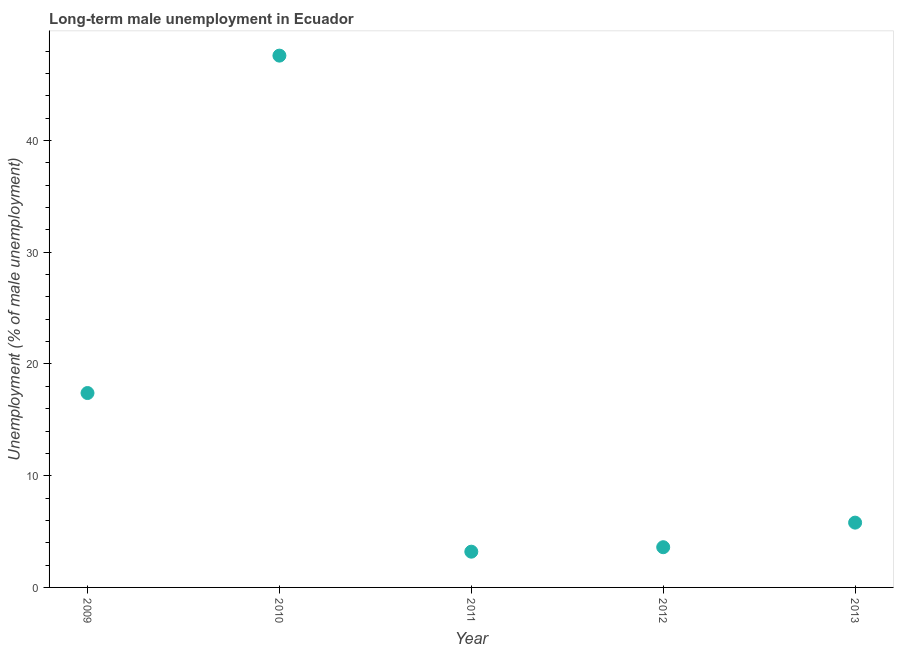What is the long-term male unemployment in 2012?
Your answer should be very brief. 3.6. Across all years, what is the maximum long-term male unemployment?
Ensure brevity in your answer.  47.6. Across all years, what is the minimum long-term male unemployment?
Make the answer very short. 3.2. What is the sum of the long-term male unemployment?
Keep it short and to the point. 77.6. What is the difference between the long-term male unemployment in 2012 and 2013?
Give a very brief answer. -2.2. What is the average long-term male unemployment per year?
Provide a short and direct response. 15.52. What is the median long-term male unemployment?
Offer a terse response. 5.8. In how many years, is the long-term male unemployment greater than 4 %?
Provide a short and direct response. 3. What is the ratio of the long-term male unemployment in 2009 to that in 2013?
Offer a very short reply. 3. Is the long-term male unemployment in 2009 less than that in 2012?
Your answer should be compact. No. Is the difference between the long-term male unemployment in 2010 and 2011 greater than the difference between any two years?
Provide a succinct answer. Yes. What is the difference between the highest and the second highest long-term male unemployment?
Give a very brief answer. 30.2. What is the difference between the highest and the lowest long-term male unemployment?
Give a very brief answer. 44.4. In how many years, is the long-term male unemployment greater than the average long-term male unemployment taken over all years?
Give a very brief answer. 2. Are the values on the major ticks of Y-axis written in scientific E-notation?
Your answer should be very brief. No. Does the graph contain grids?
Give a very brief answer. No. What is the title of the graph?
Your response must be concise. Long-term male unemployment in Ecuador. What is the label or title of the X-axis?
Your response must be concise. Year. What is the label or title of the Y-axis?
Offer a terse response. Unemployment (% of male unemployment). What is the Unemployment (% of male unemployment) in 2009?
Give a very brief answer. 17.4. What is the Unemployment (% of male unemployment) in 2010?
Provide a succinct answer. 47.6. What is the Unemployment (% of male unemployment) in 2011?
Provide a succinct answer. 3.2. What is the Unemployment (% of male unemployment) in 2012?
Offer a terse response. 3.6. What is the Unemployment (% of male unemployment) in 2013?
Offer a terse response. 5.8. What is the difference between the Unemployment (% of male unemployment) in 2009 and 2010?
Ensure brevity in your answer.  -30.2. What is the difference between the Unemployment (% of male unemployment) in 2009 and 2013?
Make the answer very short. 11.6. What is the difference between the Unemployment (% of male unemployment) in 2010 and 2011?
Provide a short and direct response. 44.4. What is the difference between the Unemployment (% of male unemployment) in 2010 and 2013?
Offer a very short reply. 41.8. What is the difference between the Unemployment (% of male unemployment) in 2012 and 2013?
Your answer should be very brief. -2.2. What is the ratio of the Unemployment (% of male unemployment) in 2009 to that in 2010?
Your answer should be compact. 0.37. What is the ratio of the Unemployment (% of male unemployment) in 2009 to that in 2011?
Ensure brevity in your answer.  5.44. What is the ratio of the Unemployment (% of male unemployment) in 2009 to that in 2012?
Provide a succinct answer. 4.83. What is the ratio of the Unemployment (% of male unemployment) in 2009 to that in 2013?
Ensure brevity in your answer.  3. What is the ratio of the Unemployment (% of male unemployment) in 2010 to that in 2011?
Offer a very short reply. 14.88. What is the ratio of the Unemployment (% of male unemployment) in 2010 to that in 2012?
Your answer should be compact. 13.22. What is the ratio of the Unemployment (% of male unemployment) in 2010 to that in 2013?
Provide a short and direct response. 8.21. What is the ratio of the Unemployment (% of male unemployment) in 2011 to that in 2012?
Ensure brevity in your answer.  0.89. What is the ratio of the Unemployment (% of male unemployment) in 2011 to that in 2013?
Give a very brief answer. 0.55. What is the ratio of the Unemployment (% of male unemployment) in 2012 to that in 2013?
Give a very brief answer. 0.62. 